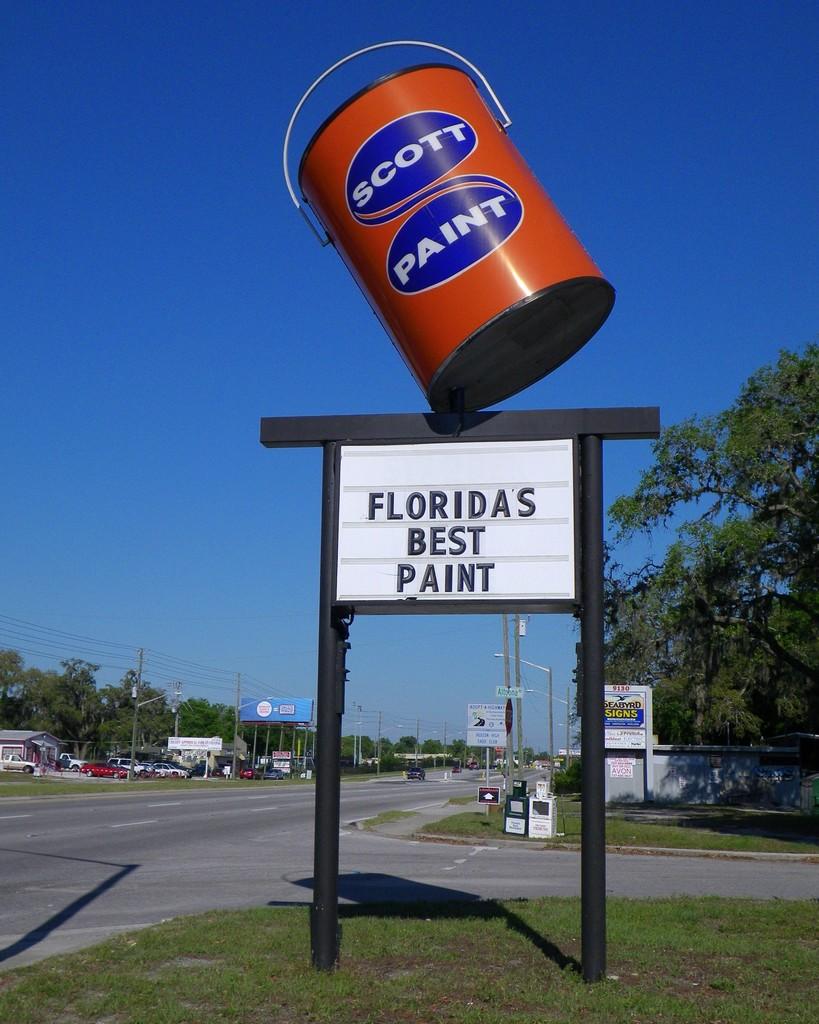What state is mentioned on this business's sign?
Your answer should be very brief. Florida. 